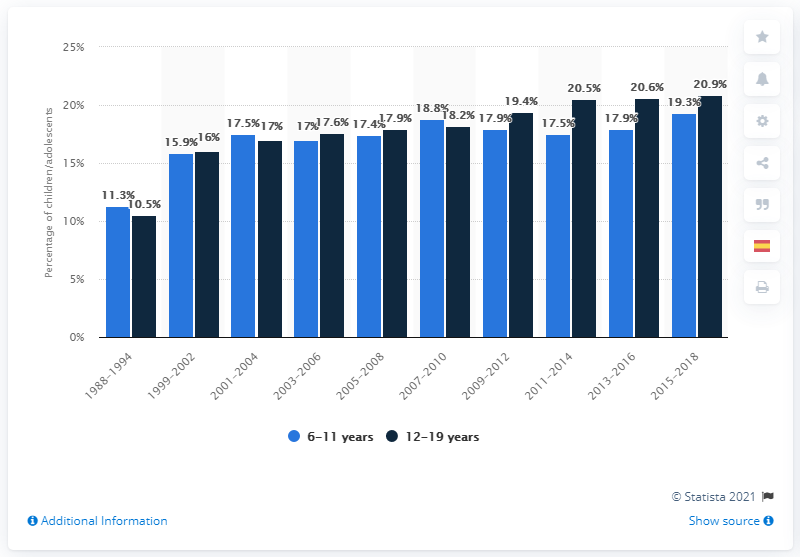Draw attention to some important aspects in this diagram. During the 2003-2006 period, it was found that 17% of children aged 6 to 11 were obese. In the period between 2011 and 2014, the difference in obesity rates between children aged 6-11 years and adolescents aged 12-19 years was at its maximum. 